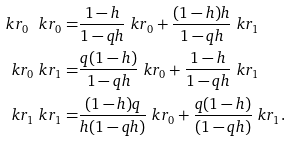<formula> <loc_0><loc_0><loc_500><loc_500>\ k r _ { 0 } \ k r _ { 0 } = & \frac { 1 - h } { 1 - q h } \ k r _ { 0 } + \frac { ( 1 - h ) h } { 1 - q h } \ k r _ { 1 } \\ \ k r _ { 0 } \ k r _ { 1 } = & \frac { q ( 1 - h ) } { 1 - q h } \ k r _ { 0 } + \frac { 1 - h } { 1 - q h } \ k r _ { 1 } \\ \ k r _ { 1 } \ k r _ { 1 } = & \frac { ( 1 - h ) q } { h ( 1 - q h ) } \ k r _ { 0 } + \frac { q ( 1 - h ) } { ( 1 - q h ) } \ k r _ { 1 } .</formula> 